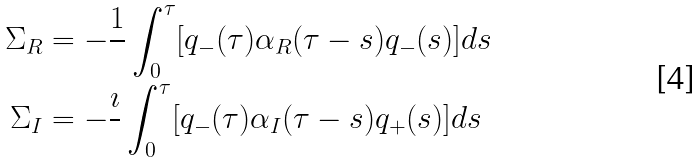<formula> <loc_0><loc_0><loc_500><loc_500>\Sigma _ { R } & = - \frac { 1 } { } \int _ { 0 } ^ { \tau } [ q _ { - } ( \tau ) \alpha _ { R } ( \tau - s ) q _ { - } ( s ) ] d s \\ \Sigma _ { I } & = - \frac { \imath } { } \int _ { 0 } ^ { \tau } [ q _ { - } ( \tau ) \alpha _ { I } ( \tau - s ) q _ { + } ( s ) ] d s</formula> 